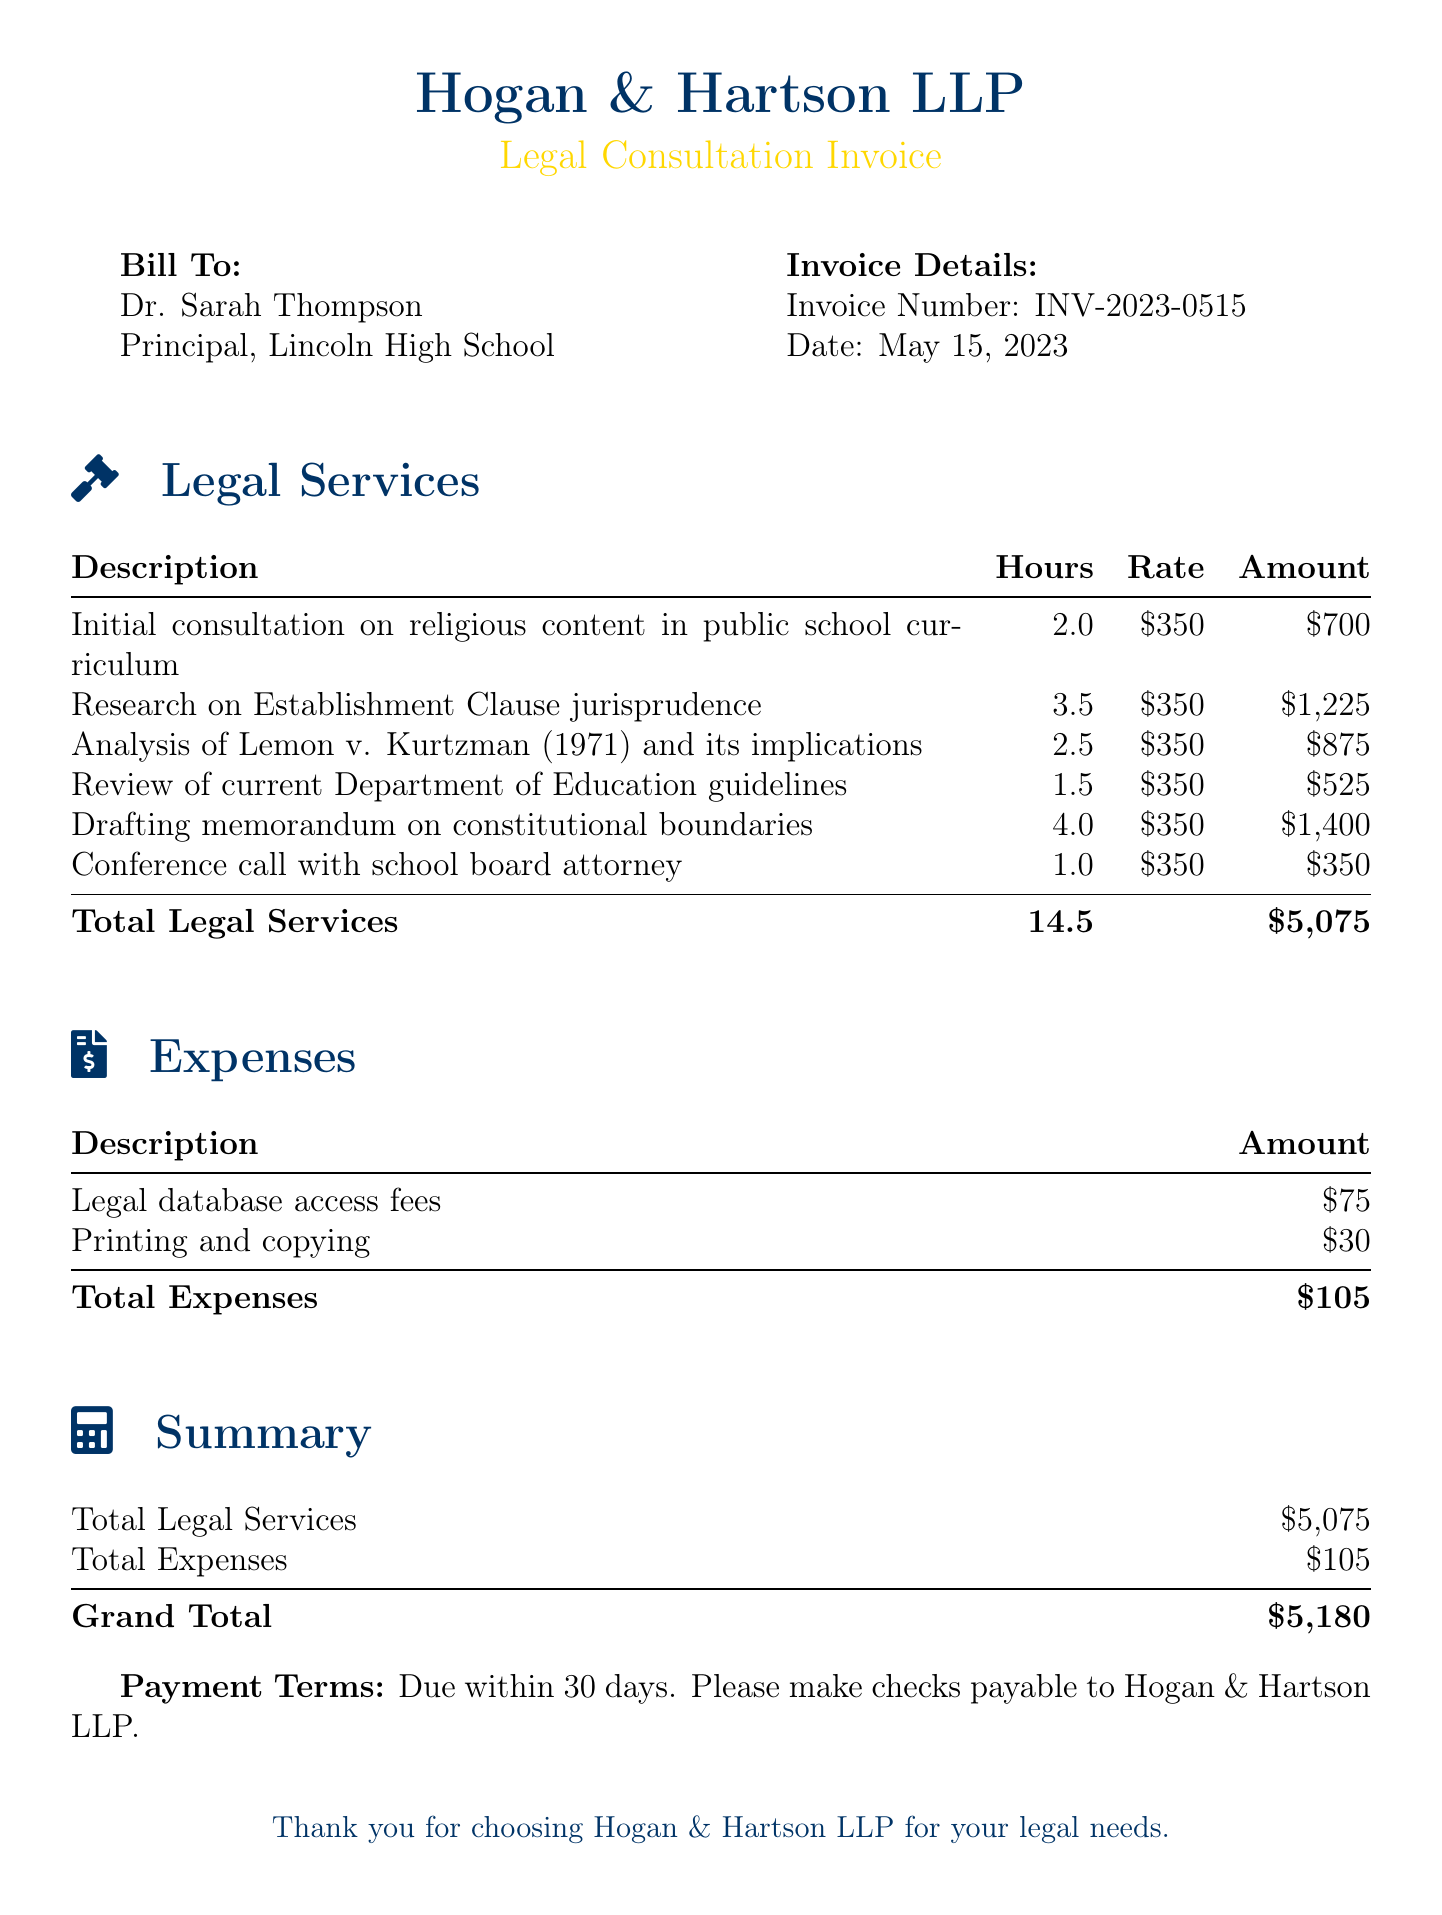What is the total amount for legal services? The total amount for legal services is provided in the summary section of the document.
Answer: $5,075 Who is the bill addressed to? The bill is addressed to the principal of Lincoln High School, as stated in the "Bill To" section.
Answer: Dr. Sarah Thompson What is the date of the invoice? The date of the invoice is indicated near the top of the document in the invoice details.
Answer: May 15, 2023 How many hours were billed for research on Establishment Clause jurisprudence? The number of hours is listed in the legal services table under that specific service.
Answer: 3.5 What expenses were incurred for legal database access? The specific expense is mentioned in the expenses section of the document.
Answer: $75 What is the invoice number? The invoice number can be found in the invoice details section.
Answer: INV-2023-0515 What is the grand total amount due? The grand total is provided in the summary section of the document.
Answer: $5,180 How many hours were spent drafting the memorandum on constitutional boundaries? The hours spent on that task can be found in the legal services table.
Answer: 4.0 What is the payment term? The payment term is stated at the bottom of the document.
Answer: Due within 30 days 